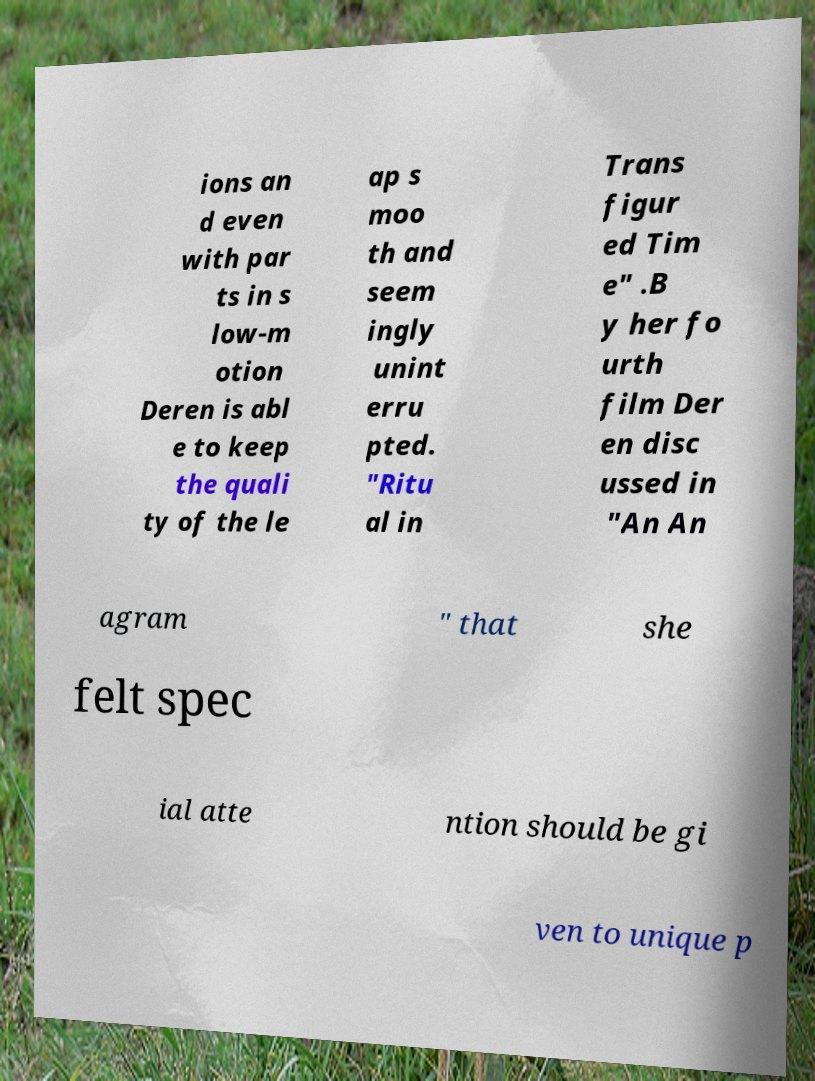For documentation purposes, I need the text within this image transcribed. Could you provide that? ions an d even with par ts in s low-m otion Deren is abl e to keep the quali ty of the le ap s moo th and seem ingly unint erru pted. "Ritu al in Trans figur ed Tim e" .B y her fo urth film Der en disc ussed in "An An agram " that she felt spec ial atte ntion should be gi ven to unique p 